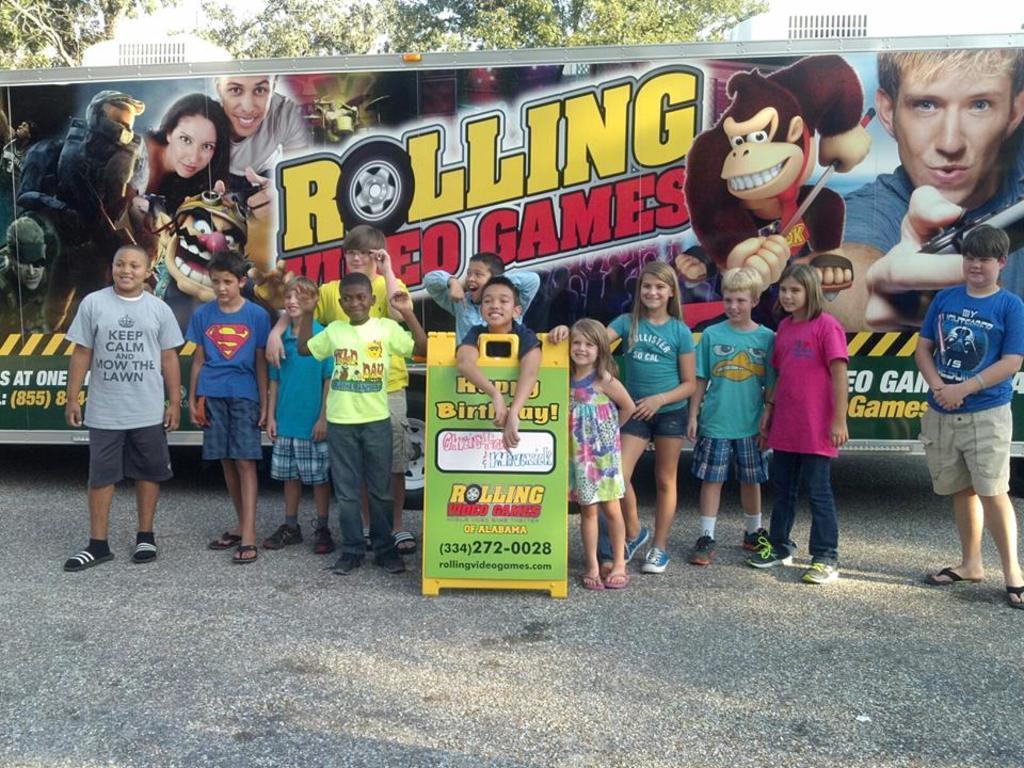Can you describe this image briefly? In the image there are many kids standing on the road in front of a banner with anime images and text on it, in the middle there is a ad board and in the background there are trees. 